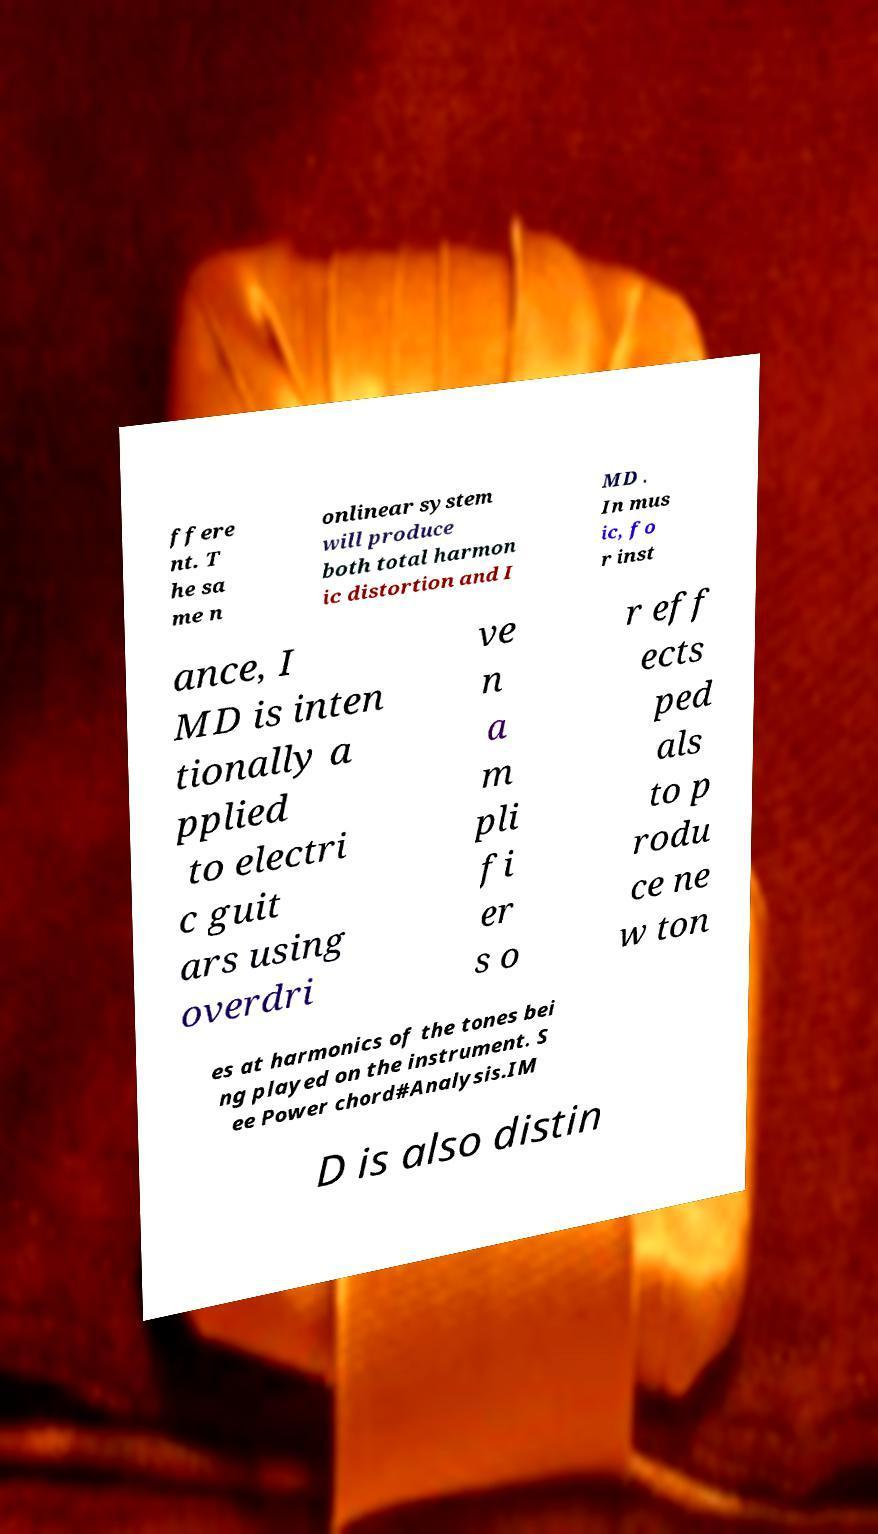There's text embedded in this image that I need extracted. Can you transcribe it verbatim? ffere nt. T he sa me n onlinear system will produce both total harmon ic distortion and I MD . In mus ic, fo r inst ance, I MD is inten tionally a pplied to electri c guit ars using overdri ve n a m pli fi er s o r eff ects ped als to p rodu ce ne w ton es at harmonics of the tones bei ng played on the instrument. S ee Power chord#Analysis.IM D is also distin 